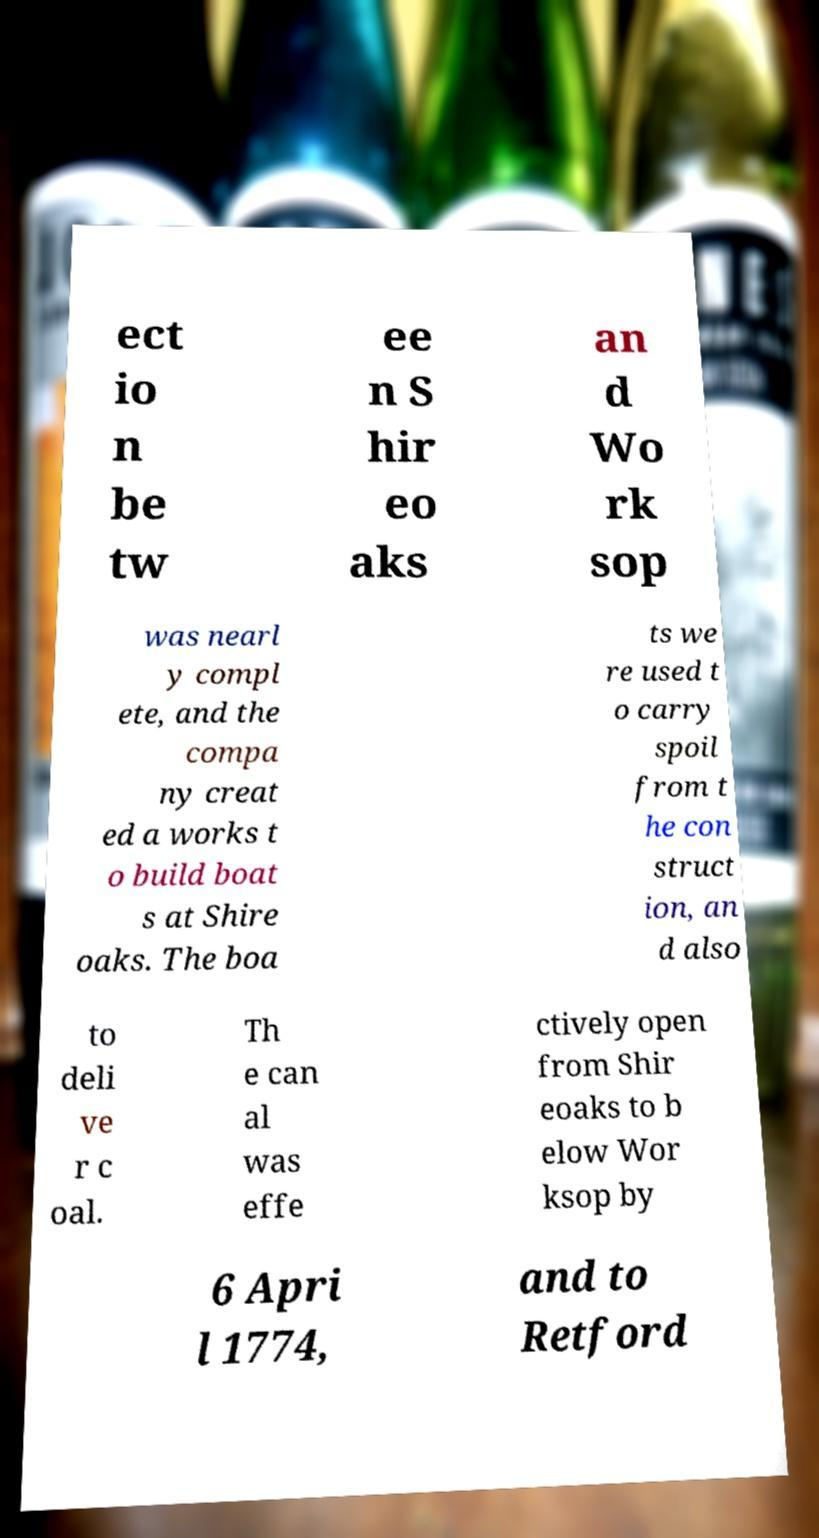For documentation purposes, I need the text within this image transcribed. Could you provide that? ect io n be tw ee n S hir eo aks an d Wo rk sop was nearl y compl ete, and the compa ny creat ed a works t o build boat s at Shire oaks. The boa ts we re used t o carry spoil from t he con struct ion, an d also to deli ve r c oal. Th e can al was effe ctively open from Shir eoaks to b elow Wor ksop by 6 Apri l 1774, and to Retford 